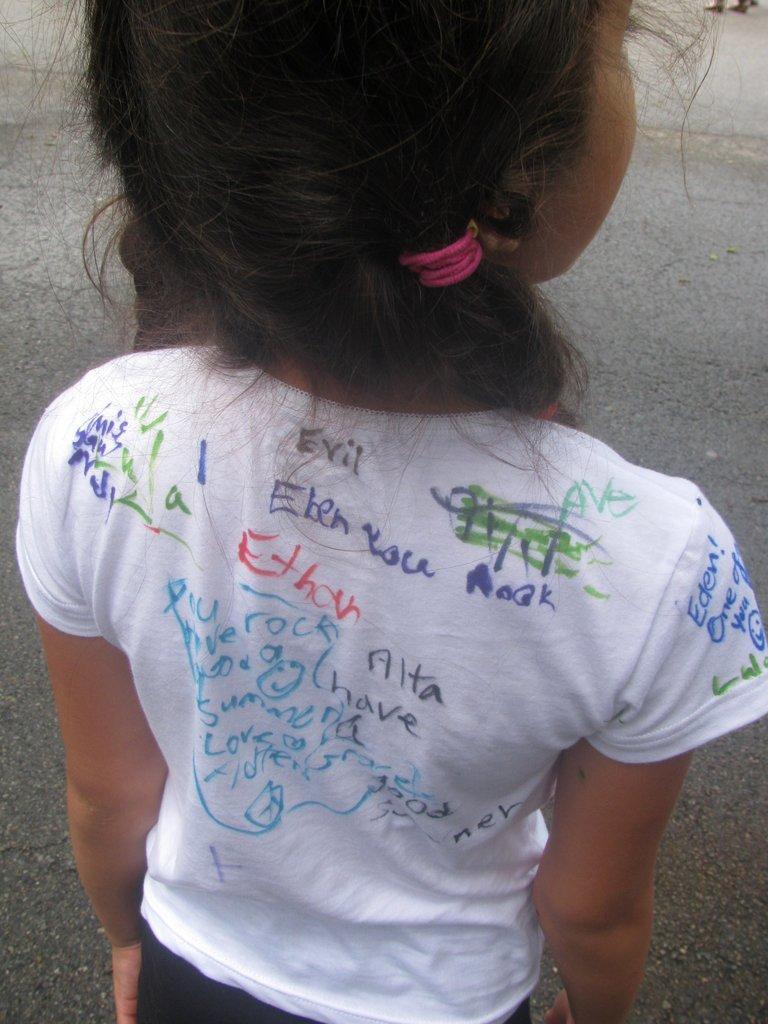Describe this image in one or two sentences. In this picture I can see a girl is standing. The girl is wearing white color t-shirt on which something written on it. In the background I can see a road. 